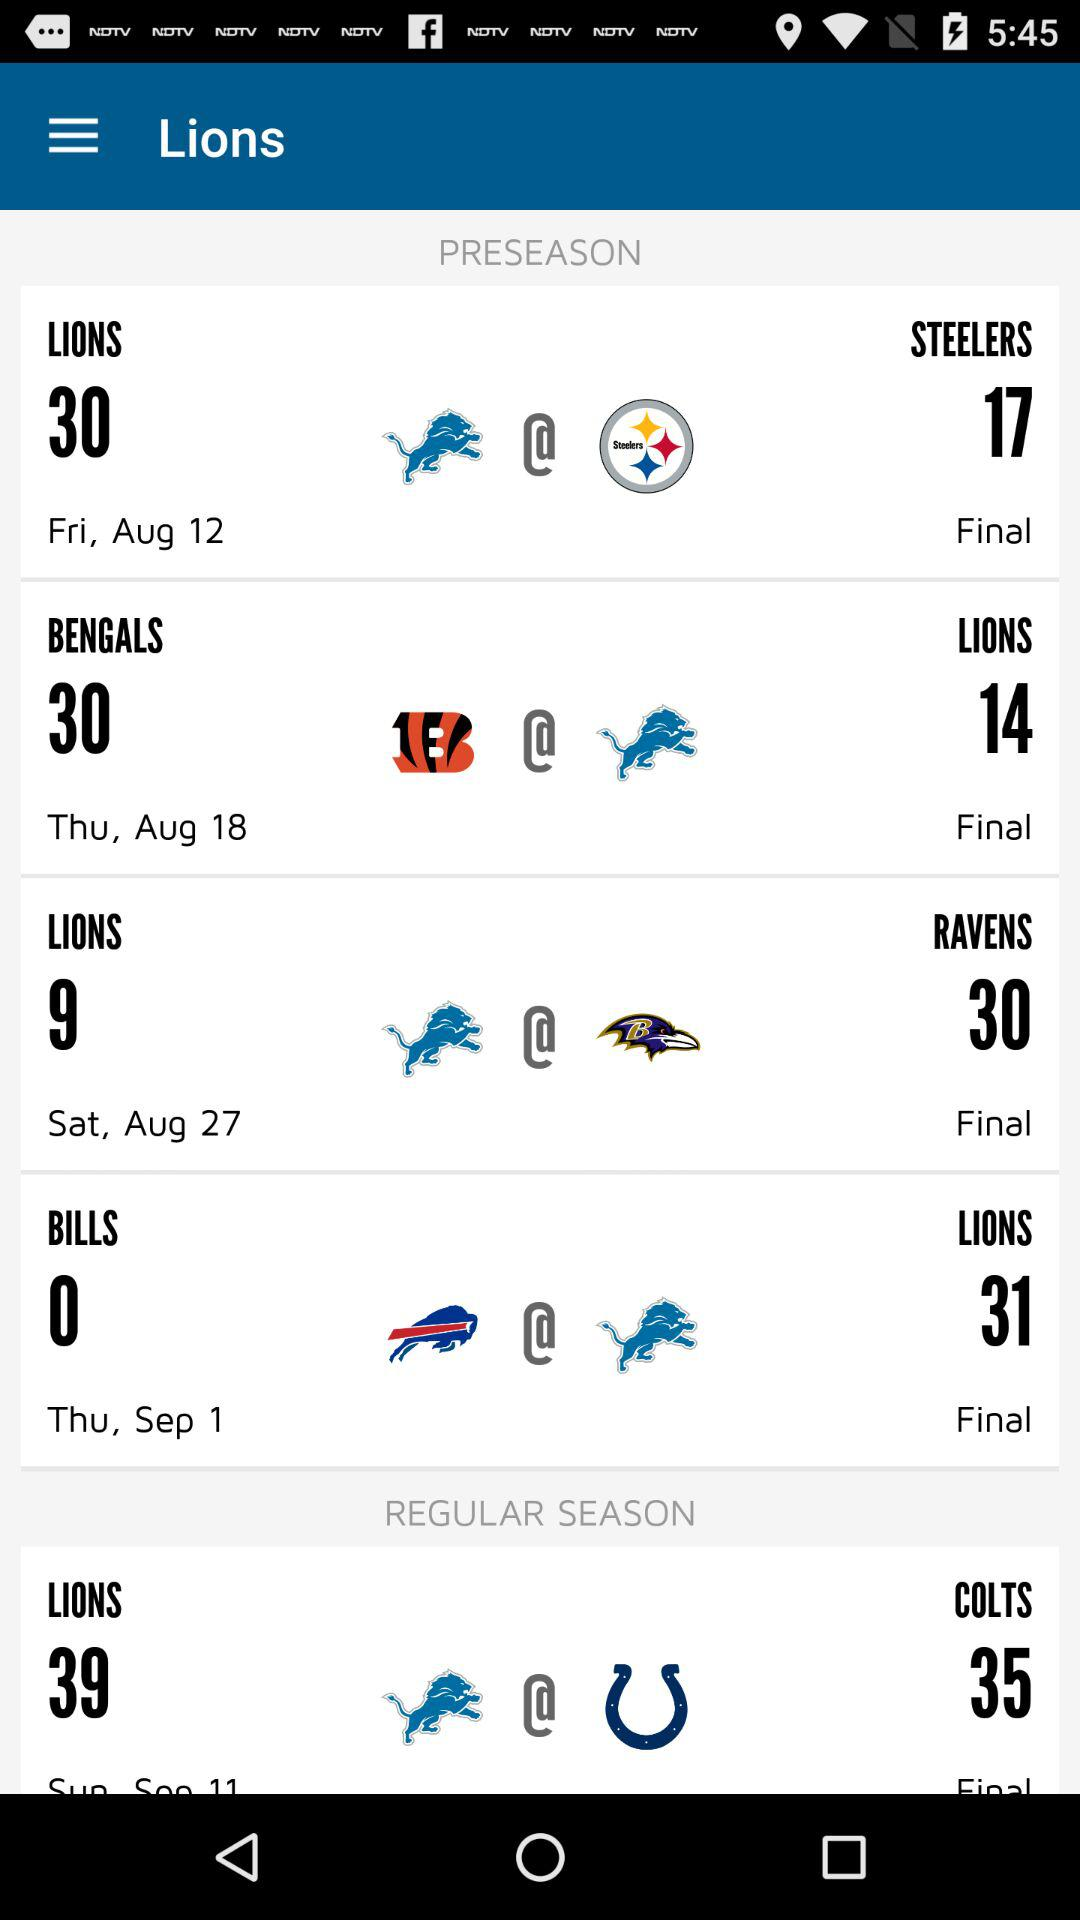What was the date of the match between "LIONS" and "RAVENS" in "PRESEASON"? The date was Saturday, August 27. 